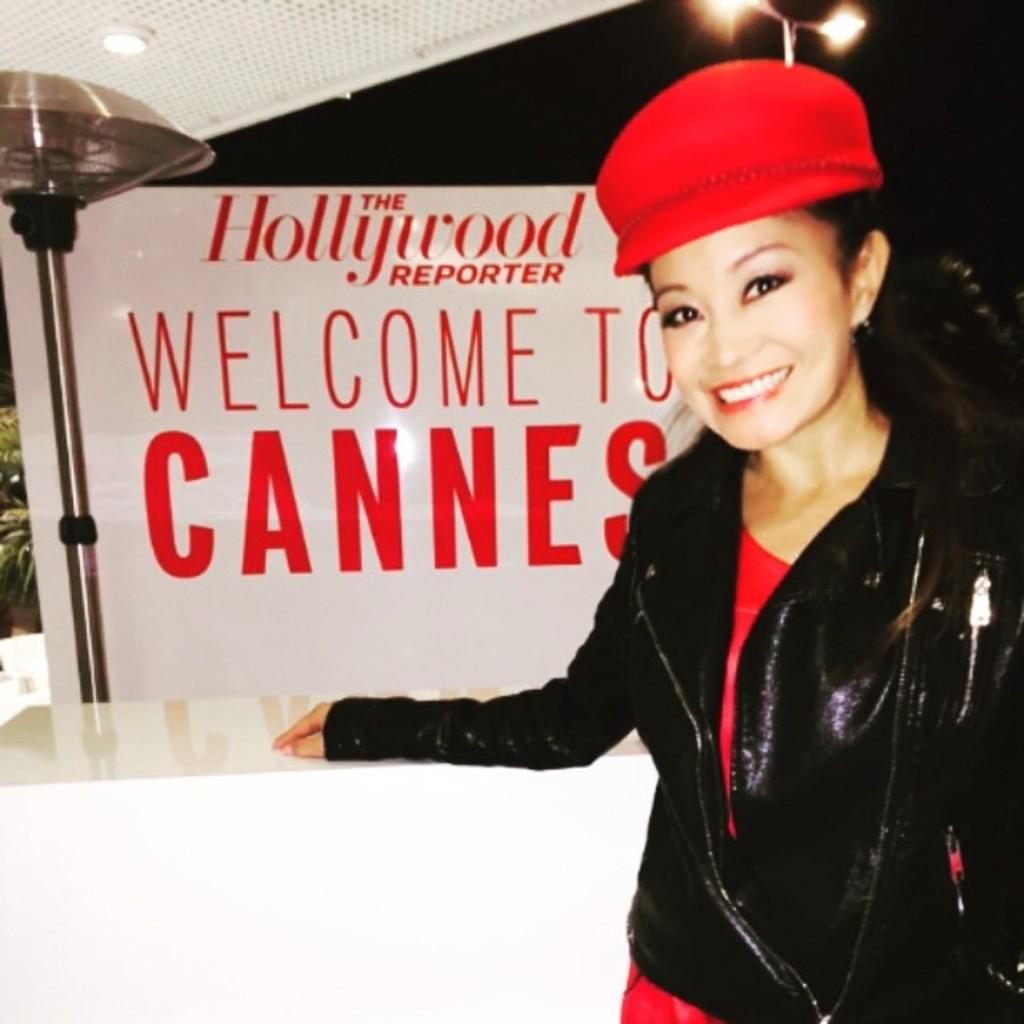What is the woman doing in the image? The woman is standing at the table in the image. What can be seen in the background behind the woman? There is an advertisement and light visible in the background. Can you describe the source of light in the background? There is a street light in the background. What type of scale is being used to weigh the woman in the image? There is no scale present in the image, and the woman is not being weighed. 